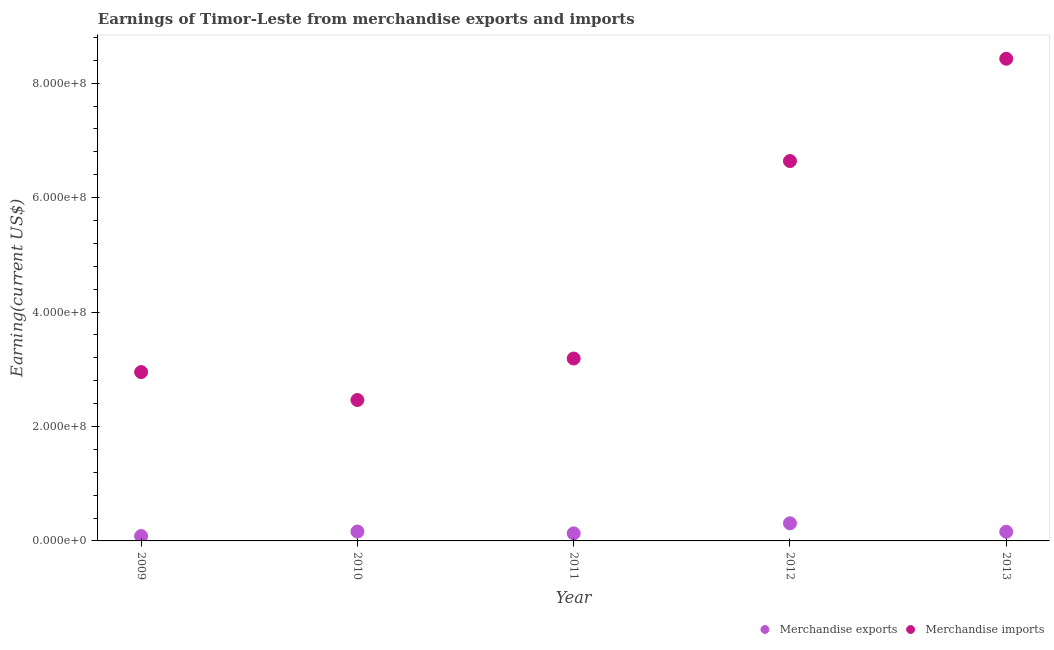Is the number of dotlines equal to the number of legend labels?
Keep it short and to the point. Yes. What is the earnings from merchandise exports in 2010?
Your answer should be compact. 1.64e+07. Across all years, what is the maximum earnings from merchandise imports?
Ensure brevity in your answer.  8.43e+08. Across all years, what is the minimum earnings from merchandise exports?
Keep it short and to the point. 8.49e+06. What is the total earnings from merchandise exports in the graph?
Make the answer very short. 8.49e+07. What is the difference between the earnings from merchandise exports in 2011 and that in 2012?
Provide a succinct answer. -1.76e+07. What is the difference between the earnings from merchandise imports in 2012 and the earnings from merchandise exports in 2009?
Your answer should be compact. 6.56e+08. What is the average earnings from merchandise imports per year?
Offer a terse response. 4.73e+08. In the year 2010, what is the difference between the earnings from merchandise exports and earnings from merchandise imports?
Keep it short and to the point. -2.30e+08. In how many years, is the earnings from merchandise imports greater than 40000000 US$?
Give a very brief answer. 5. What is the ratio of the earnings from merchandise imports in 2010 to that in 2012?
Offer a very short reply. 0.37. What is the difference between the highest and the second highest earnings from merchandise exports?
Offer a very short reply. 1.44e+07. What is the difference between the highest and the lowest earnings from merchandise exports?
Provide a short and direct response. 2.23e+07. In how many years, is the earnings from merchandise exports greater than the average earnings from merchandise exports taken over all years?
Ensure brevity in your answer.  1. Does the earnings from merchandise imports monotonically increase over the years?
Give a very brief answer. No. How many dotlines are there?
Your answer should be compact. 2. What is the difference between two consecutive major ticks on the Y-axis?
Your answer should be very brief. 2.00e+08. Are the values on the major ticks of Y-axis written in scientific E-notation?
Your response must be concise. Yes. How many legend labels are there?
Give a very brief answer. 2. How are the legend labels stacked?
Keep it short and to the point. Horizontal. What is the title of the graph?
Offer a very short reply. Earnings of Timor-Leste from merchandise exports and imports. Does "IMF concessional" appear as one of the legend labels in the graph?
Keep it short and to the point. No. What is the label or title of the X-axis?
Your answer should be very brief. Year. What is the label or title of the Y-axis?
Your response must be concise. Earning(current US$). What is the Earning(current US$) in Merchandise exports in 2009?
Give a very brief answer. 8.49e+06. What is the Earning(current US$) in Merchandise imports in 2009?
Your response must be concise. 2.95e+08. What is the Earning(current US$) in Merchandise exports in 2010?
Your answer should be very brief. 1.64e+07. What is the Earning(current US$) in Merchandise imports in 2010?
Ensure brevity in your answer.  2.46e+08. What is the Earning(current US$) of Merchandise exports in 2011?
Provide a short and direct response. 1.32e+07. What is the Earning(current US$) of Merchandise imports in 2011?
Offer a very short reply. 3.19e+08. What is the Earning(current US$) of Merchandise exports in 2012?
Provide a succinct answer. 3.08e+07. What is the Earning(current US$) of Merchandise imports in 2012?
Make the answer very short. 6.64e+08. What is the Earning(current US$) of Merchandise exports in 2013?
Offer a very short reply. 1.60e+07. What is the Earning(current US$) in Merchandise imports in 2013?
Offer a very short reply. 8.43e+08. Across all years, what is the maximum Earning(current US$) of Merchandise exports?
Provide a succinct answer. 3.08e+07. Across all years, what is the maximum Earning(current US$) of Merchandise imports?
Your response must be concise. 8.43e+08. Across all years, what is the minimum Earning(current US$) of Merchandise exports?
Ensure brevity in your answer.  8.49e+06. Across all years, what is the minimum Earning(current US$) of Merchandise imports?
Offer a very short reply. 2.46e+08. What is the total Earning(current US$) in Merchandise exports in the graph?
Your answer should be very brief. 8.49e+07. What is the total Earning(current US$) in Merchandise imports in the graph?
Your answer should be very brief. 2.37e+09. What is the difference between the Earning(current US$) in Merchandise exports in 2009 and that in 2010?
Provide a short and direct response. -7.90e+06. What is the difference between the Earning(current US$) of Merchandise imports in 2009 and that in 2010?
Your response must be concise. 4.88e+07. What is the difference between the Earning(current US$) of Merchandise exports in 2009 and that in 2011?
Your response must be concise. -4.71e+06. What is the difference between the Earning(current US$) of Merchandise imports in 2009 and that in 2011?
Your answer should be very brief. -2.37e+07. What is the difference between the Earning(current US$) in Merchandise exports in 2009 and that in 2012?
Offer a very short reply. -2.23e+07. What is the difference between the Earning(current US$) in Merchandise imports in 2009 and that in 2012?
Make the answer very short. -3.69e+08. What is the difference between the Earning(current US$) in Merchandise exports in 2009 and that in 2013?
Make the answer very short. -7.56e+06. What is the difference between the Earning(current US$) in Merchandise imports in 2009 and that in 2013?
Give a very brief answer. -5.48e+08. What is the difference between the Earning(current US$) in Merchandise exports in 2010 and that in 2011?
Your answer should be very brief. 3.19e+06. What is the difference between the Earning(current US$) in Merchandise imports in 2010 and that in 2011?
Your answer should be very brief. -7.25e+07. What is the difference between the Earning(current US$) of Merchandise exports in 2010 and that in 2012?
Your answer should be very brief. -1.44e+07. What is the difference between the Earning(current US$) of Merchandise imports in 2010 and that in 2012?
Make the answer very short. -4.18e+08. What is the difference between the Earning(current US$) in Merchandise exports in 2010 and that in 2013?
Provide a succinct answer. 3.50e+05. What is the difference between the Earning(current US$) in Merchandise imports in 2010 and that in 2013?
Give a very brief answer. -5.96e+08. What is the difference between the Earning(current US$) of Merchandise exports in 2011 and that in 2012?
Your answer should be compact. -1.76e+07. What is the difference between the Earning(current US$) in Merchandise imports in 2011 and that in 2012?
Ensure brevity in your answer.  -3.45e+08. What is the difference between the Earning(current US$) in Merchandise exports in 2011 and that in 2013?
Give a very brief answer. -2.84e+06. What is the difference between the Earning(current US$) of Merchandise imports in 2011 and that in 2013?
Keep it short and to the point. -5.24e+08. What is the difference between the Earning(current US$) of Merchandise exports in 2012 and that in 2013?
Provide a short and direct response. 1.47e+07. What is the difference between the Earning(current US$) in Merchandise imports in 2012 and that in 2013?
Give a very brief answer. -1.79e+08. What is the difference between the Earning(current US$) in Merchandise exports in 2009 and the Earning(current US$) in Merchandise imports in 2010?
Keep it short and to the point. -2.38e+08. What is the difference between the Earning(current US$) in Merchandise exports in 2009 and the Earning(current US$) in Merchandise imports in 2011?
Keep it short and to the point. -3.10e+08. What is the difference between the Earning(current US$) of Merchandise exports in 2009 and the Earning(current US$) of Merchandise imports in 2012?
Your answer should be compact. -6.56e+08. What is the difference between the Earning(current US$) of Merchandise exports in 2009 and the Earning(current US$) of Merchandise imports in 2013?
Keep it short and to the point. -8.34e+08. What is the difference between the Earning(current US$) of Merchandise exports in 2010 and the Earning(current US$) of Merchandise imports in 2011?
Ensure brevity in your answer.  -3.02e+08. What is the difference between the Earning(current US$) of Merchandise exports in 2010 and the Earning(current US$) of Merchandise imports in 2012?
Your answer should be compact. -6.48e+08. What is the difference between the Earning(current US$) in Merchandise exports in 2010 and the Earning(current US$) in Merchandise imports in 2013?
Give a very brief answer. -8.26e+08. What is the difference between the Earning(current US$) in Merchandise exports in 2011 and the Earning(current US$) in Merchandise imports in 2012?
Your answer should be very brief. -6.51e+08. What is the difference between the Earning(current US$) of Merchandise exports in 2011 and the Earning(current US$) of Merchandise imports in 2013?
Ensure brevity in your answer.  -8.30e+08. What is the difference between the Earning(current US$) of Merchandise exports in 2012 and the Earning(current US$) of Merchandise imports in 2013?
Give a very brief answer. -8.12e+08. What is the average Earning(current US$) of Merchandise exports per year?
Your answer should be very brief. 1.70e+07. What is the average Earning(current US$) in Merchandise imports per year?
Offer a very short reply. 4.73e+08. In the year 2009, what is the difference between the Earning(current US$) of Merchandise exports and Earning(current US$) of Merchandise imports?
Make the answer very short. -2.87e+08. In the year 2010, what is the difference between the Earning(current US$) of Merchandise exports and Earning(current US$) of Merchandise imports?
Provide a succinct answer. -2.30e+08. In the year 2011, what is the difference between the Earning(current US$) in Merchandise exports and Earning(current US$) in Merchandise imports?
Offer a terse response. -3.06e+08. In the year 2012, what is the difference between the Earning(current US$) in Merchandise exports and Earning(current US$) in Merchandise imports?
Your response must be concise. -6.33e+08. In the year 2013, what is the difference between the Earning(current US$) in Merchandise exports and Earning(current US$) in Merchandise imports?
Your response must be concise. -8.27e+08. What is the ratio of the Earning(current US$) of Merchandise exports in 2009 to that in 2010?
Your answer should be very brief. 0.52. What is the ratio of the Earning(current US$) in Merchandise imports in 2009 to that in 2010?
Your response must be concise. 1.2. What is the ratio of the Earning(current US$) of Merchandise exports in 2009 to that in 2011?
Offer a very short reply. 0.64. What is the ratio of the Earning(current US$) in Merchandise imports in 2009 to that in 2011?
Your response must be concise. 0.93. What is the ratio of the Earning(current US$) of Merchandise exports in 2009 to that in 2012?
Your response must be concise. 0.28. What is the ratio of the Earning(current US$) of Merchandise imports in 2009 to that in 2012?
Keep it short and to the point. 0.44. What is the ratio of the Earning(current US$) of Merchandise exports in 2009 to that in 2013?
Provide a short and direct response. 0.53. What is the ratio of the Earning(current US$) in Merchandise imports in 2009 to that in 2013?
Your answer should be very brief. 0.35. What is the ratio of the Earning(current US$) of Merchandise exports in 2010 to that in 2011?
Your answer should be compact. 1.24. What is the ratio of the Earning(current US$) of Merchandise imports in 2010 to that in 2011?
Make the answer very short. 0.77. What is the ratio of the Earning(current US$) of Merchandise exports in 2010 to that in 2012?
Your answer should be compact. 0.53. What is the ratio of the Earning(current US$) in Merchandise imports in 2010 to that in 2012?
Give a very brief answer. 0.37. What is the ratio of the Earning(current US$) in Merchandise exports in 2010 to that in 2013?
Offer a very short reply. 1.02. What is the ratio of the Earning(current US$) of Merchandise imports in 2010 to that in 2013?
Offer a very short reply. 0.29. What is the ratio of the Earning(current US$) in Merchandise exports in 2011 to that in 2012?
Offer a very short reply. 0.43. What is the ratio of the Earning(current US$) of Merchandise imports in 2011 to that in 2012?
Your response must be concise. 0.48. What is the ratio of the Earning(current US$) in Merchandise exports in 2011 to that in 2013?
Offer a very short reply. 0.82. What is the ratio of the Earning(current US$) in Merchandise imports in 2011 to that in 2013?
Keep it short and to the point. 0.38. What is the ratio of the Earning(current US$) in Merchandise exports in 2012 to that in 2013?
Make the answer very short. 1.92. What is the ratio of the Earning(current US$) of Merchandise imports in 2012 to that in 2013?
Make the answer very short. 0.79. What is the difference between the highest and the second highest Earning(current US$) of Merchandise exports?
Ensure brevity in your answer.  1.44e+07. What is the difference between the highest and the second highest Earning(current US$) of Merchandise imports?
Make the answer very short. 1.79e+08. What is the difference between the highest and the lowest Earning(current US$) of Merchandise exports?
Give a very brief answer. 2.23e+07. What is the difference between the highest and the lowest Earning(current US$) in Merchandise imports?
Make the answer very short. 5.96e+08. 